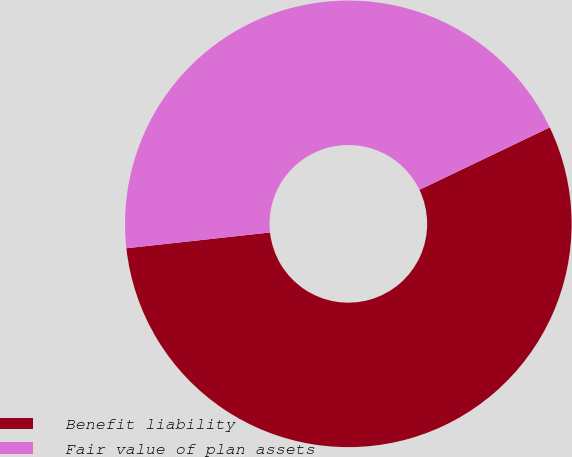Convert chart. <chart><loc_0><loc_0><loc_500><loc_500><pie_chart><fcel>Benefit liability<fcel>Fair value of plan assets<nl><fcel>55.36%<fcel>44.64%<nl></chart> 